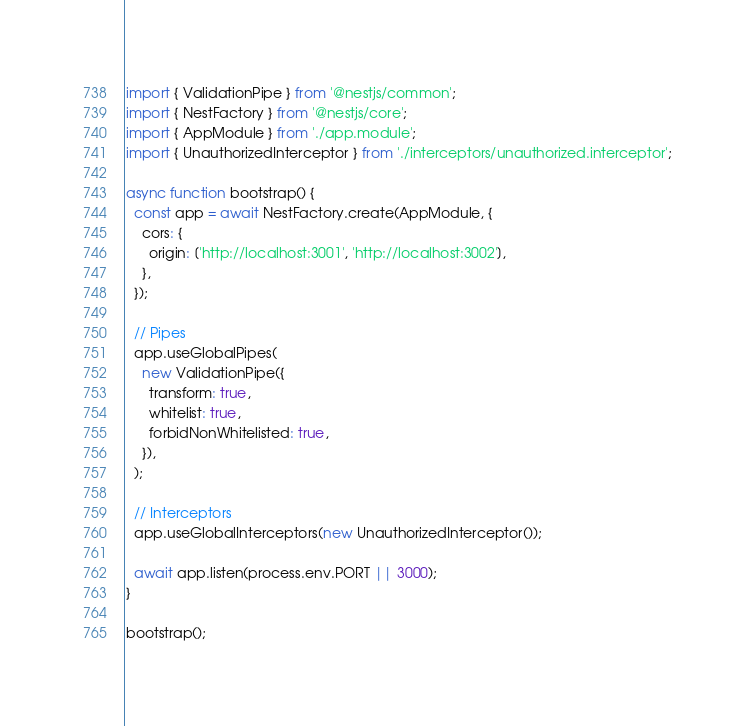Convert code to text. <code><loc_0><loc_0><loc_500><loc_500><_TypeScript_>import { ValidationPipe } from '@nestjs/common';
import { NestFactory } from '@nestjs/core';
import { AppModule } from './app.module';
import { UnauthorizedInterceptor } from './interceptors/unauthorized.interceptor';

async function bootstrap() {
  const app = await NestFactory.create(AppModule, {
    cors: {
      origin: ['http://localhost:3001', 'http://localhost:3002'],
    },
  });

  // Pipes
  app.useGlobalPipes(
    new ValidationPipe({
      transform: true,
      whitelist: true,
      forbidNonWhitelisted: true,
    }),
  );

  // Interceptors
  app.useGlobalInterceptors(new UnauthorizedInterceptor());

  await app.listen(process.env.PORT || 3000);
}

bootstrap();
</code> 